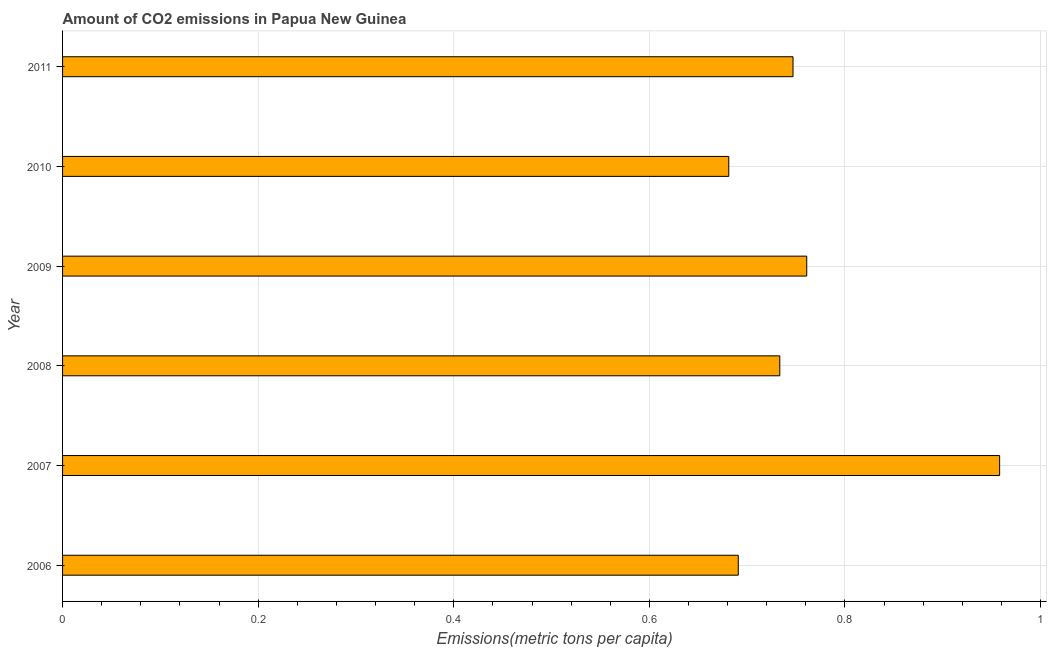What is the title of the graph?
Make the answer very short. Amount of CO2 emissions in Papua New Guinea. What is the label or title of the X-axis?
Provide a short and direct response. Emissions(metric tons per capita). What is the label or title of the Y-axis?
Give a very brief answer. Year. What is the amount of co2 emissions in 2010?
Give a very brief answer. 0.68. Across all years, what is the maximum amount of co2 emissions?
Your answer should be compact. 0.96. Across all years, what is the minimum amount of co2 emissions?
Ensure brevity in your answer.  0.68. In which year was the amount of co2 emissions minimum?
Your answer should be compact. 2010. What is the sum of the amount of co2 emissions?
Keep it short and to the point. 4.57. What is the difference between the amount of co2 emissions in 2009 and 2011?
Offer a very short reply. 0.01. What is the average amount of co2 emissions per year?
Give a very brief answer. 0.76. What is the median amount of co2 emissions?
Your answer should be compact. 0.74. What is the ratio of the amount of co2 emissions in 2006 to that in 2009?
Ensure brevity in your answer.  0.91. Is the difference between the amount of co2 emissions in 2006 and 2009 greater than the difference between any two years?
Provide a succinct answer. No. What is the difference between the highest and the second highest amount of co2 emissions?
Your answer should be very brief. 0.2. Is the sum of the amount of co2 emissions in 2006 and 2009 greater than the maximum amount of co2 emissions across all years?
Provide a succinct answer. Yes. What is the difference between the highest and the lowest amount of co2 emissions?
Offer a terse response. 0.28. How many bars are there?
Offer a very short reply. 6. How many years are there in the graph?
Ensure brevity in your answer.  6. What is the difference between two consecutive major ticks on the X-axis?
Your answer should be very brief. 0.2. What is the Emissions(metric tons per capita) in 2006?
Your answer should be compact. 0.69. What is the Emissions(metric tons per capita) of 2007?
Keep it short and to the point. 0.96. What is the Emissions(metric tons per capita) in 2008?
Ensure brevity in your answer.  0.73. What is the Emissions(metric tons per capita) in 2009?
Your answer should be compact. 0.76. What is the Emissions(metric tons per capita) of 2010?
Give a very brief answer. 0.68. What is the Emissions(metric tons per capita) in 2011?
Your answer should be compact. 0.75. What is the difference between the Emissions(metric tons per capita) in 2006 and 2007?
Your answer should be compact. -0.27. What is the difference between the Emissions(metric tons per capita) in 2006 and 2008?
Your answer should be very brief. -0.04. What is the difference between the Emissions(metric tons per capita) in 2006 and 2009?
Your answer should be compact. -0.07. What is the difference between the Emissions(metric tons per capita) in 2006 and 2010?
Ensure brevity in your answer.  0.01. What is the difference between the Emissions(metric tons per capita) in 2006 and 2011?
Offer a very short reply. -0.06. What is the difference between the Emissions(metric tons per capita) in 2007 and 2008?
Your answer should be very brief. 0.22. What is the difference between the Emissions(metric tons per capita) in 2007 and 2009?
Offer a terse response. 0.2. What is the difference between the Emissions(metric tons per capita) in 2007 and 2010?
Your response must be concise. 0.28. What is the difference between the Emissions(metric tons per capita) in 2007 and 2011?
Offer a terse response. 0.21. What is the difference between the Emissions(metric tons per capita) in 2008 and 2009?
Your response must be concise. -0.03. What is the difference between the Emissions(metric tons per capita) in 2008 and 2010?
Offer a terse response. 0.05. What is the difference between the Emissions(metric tons per capita) in 2008 and 2011?
Provide a short and direct response. -0.01. What is the difference between the Emissions(metric tons per capita) in 2009 and 2010?
Ensure brevity in your answer.  0.08. What is the difference between the Emissions(metric tons per capita) in 2009 and 2011?
Your answer should be very brief. 0.01. What is the difference between the Emissions(metric tons per capita) in 2010 and 2011?
Your response must be concise. -0.07. What is the ratio of the Emissions(metric tons per capita) in 2006 to that in 2007?
Provide a succinct answer. 0.72. What is the ratio of the Emissions(metric tons per capita) in 2006 to that in 2008?
Your answer should be compact. 0.94. What is the ratio of the Emissions(metric tons per capita) in 2006 to that in 2009?
Offer a very short reply. 0.91. What is the ratio of the Emissions(metric tons per capita) in 2006 to that in 2010?
Keep it short and to the point. 1.01. What is the ratio of the Emissions(metric tons per capita) in 2006 to that in 2011?
Provide a short and direct response. 0.93. What is the ratio of the Emissions(metric tons per capita) in 2007 to that in 2008?
Your response must be concise. 1.31. What is the ratio of the Emissions(metric tons per capita) in 2007 to that in 2009?
Your response must be concise. 1.26. What is the ratio of the Emissions(metric tons per capita) in 2007 to that in 2010?
Provide a succinct answer. 1.41. What is the ratio of the Emissions(metric tons per capita) in 2007 to that in 2011?
Ensure brevity in your answer.  1.28. What is the ratio of the Emissions(metric tons per capita) in 2008 to that in 2010?
Offer a very short reply. 1.08. What is the ratio of the Emissions(metric tons per capita) in 2008 to that in 2011?
Offer a terse response. 0.98. What is the ratio of the Emissions(metric tons per capita) in 2009 to that in 2010?
Make the answer very short. 1.12. What is the ratio of the Emissions(metric tons per capita) in 2010 to that in 2011?
Provide a short and direct response. 0.91. 